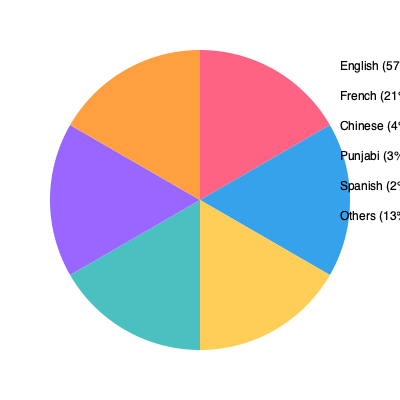The pie chart shows the distribution of languages spoken in Canada. If the total population of Canada is 38 million, approximately how many people speak French as their primary language? To solve this problem, we need to follow these steps:

1. Identify the percentage of French speakers from the pie chart:
   French speakers account for 21% of the population.

2. Calculate 21% of the total population:
   $21\% = \frac{21}{100} = 0.21$

3. Multiply the total population by 0.21:
   $38,000,000 \times 0.21 = 7,980,000$

Therefore, approximately 7,980,000 people in Canada speak French as their primary language.
Answer: 7,980,000 people 